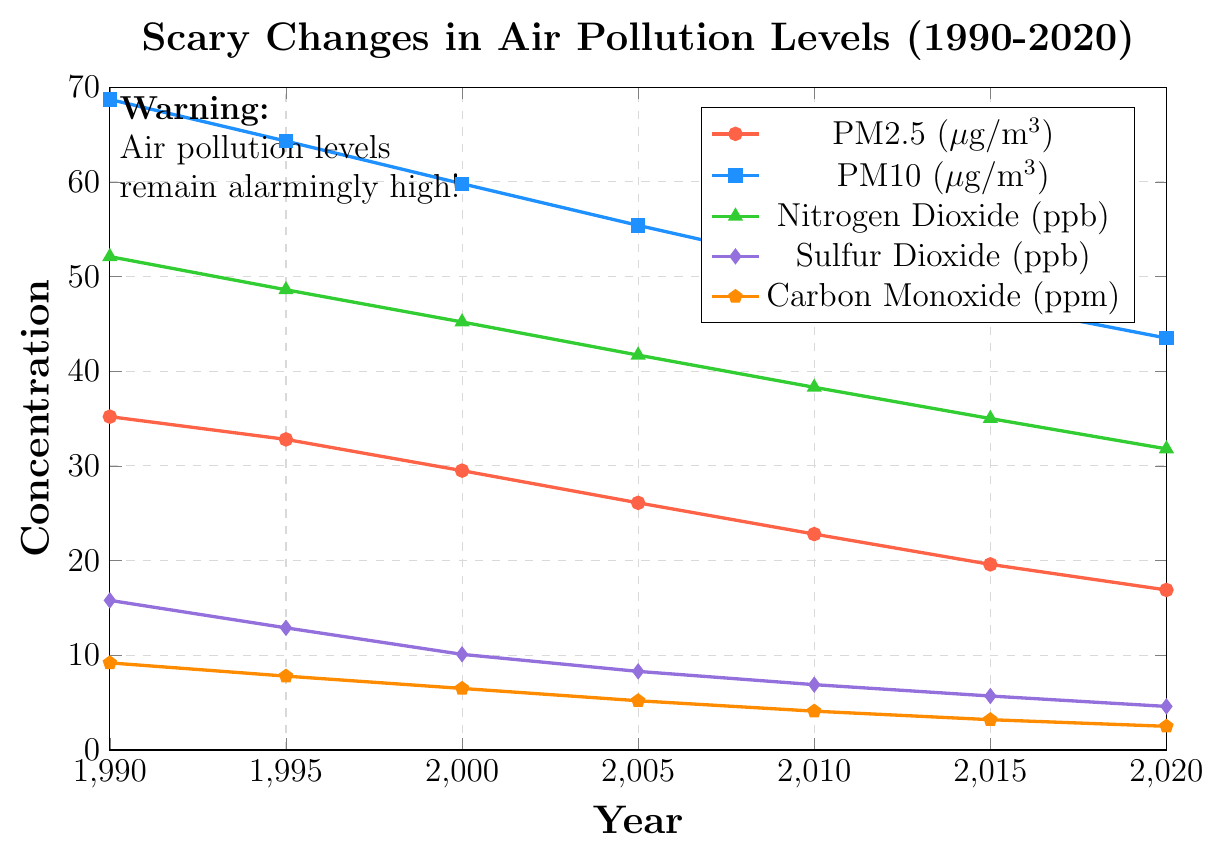Which pollutant has experienced the greatest reduction in levels from 1990 to 2020? To find the greatest reduction, subtract the level in 2020 from the level in 1990 for each pollutant: PM2.5: 35.2 - 16.9 = 18.3, PM10: 68.7 - 43.5 = 25.2, Nitrogen Dioxide: 52.1 - 31.8 = 20.3, Sulfur Dioxide: 15.8 - 4.6 = 11.2, Carbon Monoxide: 9.2 - 2.5 = 6.7. The largest reduction is for PM10.
Answer: PM10 What is the average concentration of PM2.5 over the period from 1990 to 2020? Sum the PM2.5 levels over all the years and divide by the number of years: (35.2 + 32.8 + 29.5 + 26.1 + 22.8 + 19.6 + 16.9) / 7 = 182.9 / 7 = 26.13
Answer: 26.13 Between which two consecutive years does Sulfur Dioxide see the largest drop? Calculate the difference between each pair of consecutive years for Sulfur Dioxide: 1990 to 1995: 15.8 - 12.9 = 2.9, 1995 to 2000: 12.9 - 10.1 = 2.8, 2000 to 2005: 10.1 - 8.3 = 1.8, 2005 to 2010: 8.3 - 6.9 = 1.4, 2010 to 2015: 6.9 - 5.7 = 1.2, 2015 to 2020: 5.7 - 4.6 = 1.1. The largest drop is from 1990 to 1995.
Answer: 1990 to 1995 Which pollutant has the smallest range of concentration changes over the years? Calculate the range for each pollutant: PM2.5: 35.2 - 16.9 = 18.3, PM10: 68.7 - 43.5 = 25.2, Nitrogen Dioxide: 52.1 - 31.8 = 20.3, Sulfur Dioxide: 15.8 - 4.6 = 11.2, Carbon Monoxide: 9.2 - 2.5 = 6.7. The smallest range is for Carbon Monoxide.
Answer: Carbon Monoxide In what year was the concentration of Nitrogen Dioxide approximately equal to 40 ppb? Look for the year where Nitrogen Dioxide is close to 40 ppb: In 2005, Nitrogen Dioxide was at 41.7 ppb.
Answer: 2005 How does the concentration of Carbon Monoxide in 2020 compare to its concentration in 2000? Compare the levels of Carbon Monoxide in 2020 and 2000: 2.5 ppm in 2020 and 6.5 ppm in 2000. It decreased significantly.
Answer: Decreased What is the difference in PM10 concentration levels between 1990 and 2010? Subtract the PM10 level in 2010 from the level in 1990: 68.7 - 51.2 = 17.5
Answer: 17.5 What is the overall trend observed in the levels of PM2.5 from 1990 to 2020? Evaluate the PM2.5 levels from 1990 to 2020: They consistently decrease from 35.2 μg/m³ to 16.9 μg/m³ over the years.
Answer: Decreasing Which year shows the lowest levels for Sulfur Dioxide? Identify the year with the lowest Sulfur Dioxide level: The values decrease continually, with the lowest in 2020 at 4.6 ppb.
Answer: 2020 